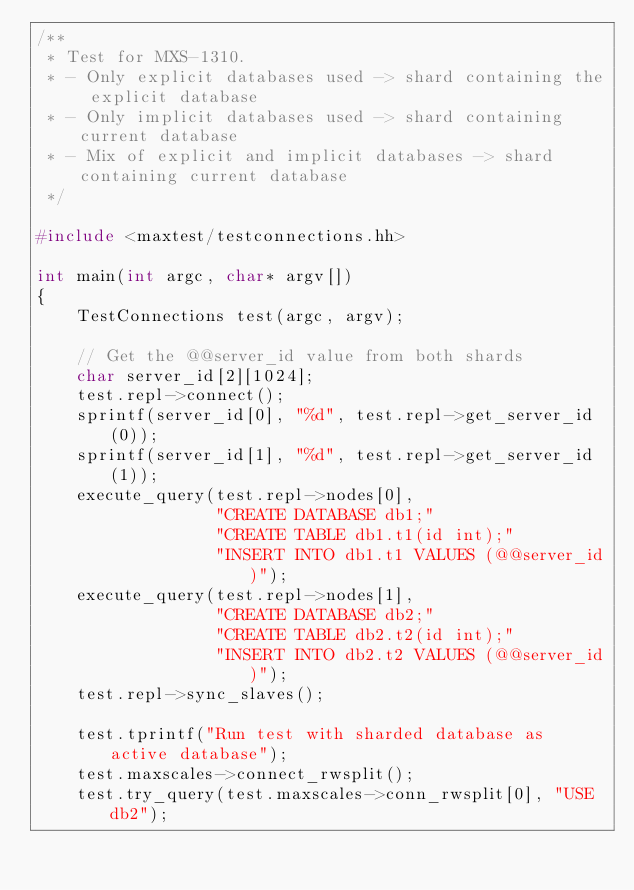<code> <loc_0><loc_0><loc_500><loc_500><_C++_>/**
 * Test for MXS-1310.
 * - Only explicit databases used -> shard containing the explicit database
 * - Only implicit databases used -> shard containing current database
 * - Mix of explicit and implicit databases -> shard containing current database
 */

#include <maxtest/testconnections.hh>

int main(int argc, char* argv[])
{
    TestConnections test(argc, argv);

    // Get the @@server_id value from both shards
    char server_id[2][1024];
    test.repl->connect();
    sprintf(server_id[0], "%d", test.repl->get_server_id(0));
    sprintf(server_id[1], "%d", test.repl->get_server_id(1));
    execute_query(test.repl->nodes[0],
                  "CREATE DATABASE db1;"
                  "CREATE TABLE db1.t1(id int);"
                  "INSERT INTO db1.t1 VALUES (@@server_id)");
    execute_query(test.repl->nodes[1],
                  "CREATE DATABASE db2;"
                  "CREATE TABLE db2.t2(id int);"
                  "INSERT INTO db2.t2 VALUES (@@server_id)");
    test.repl->sync_slaves();

    test.tprintf("Run test with sharded database as active database");
    test.maxscales->connect_rwsplit();
    test.try_query(test.maxscales->conn_rwsplit[0], "USE db2");</code> 